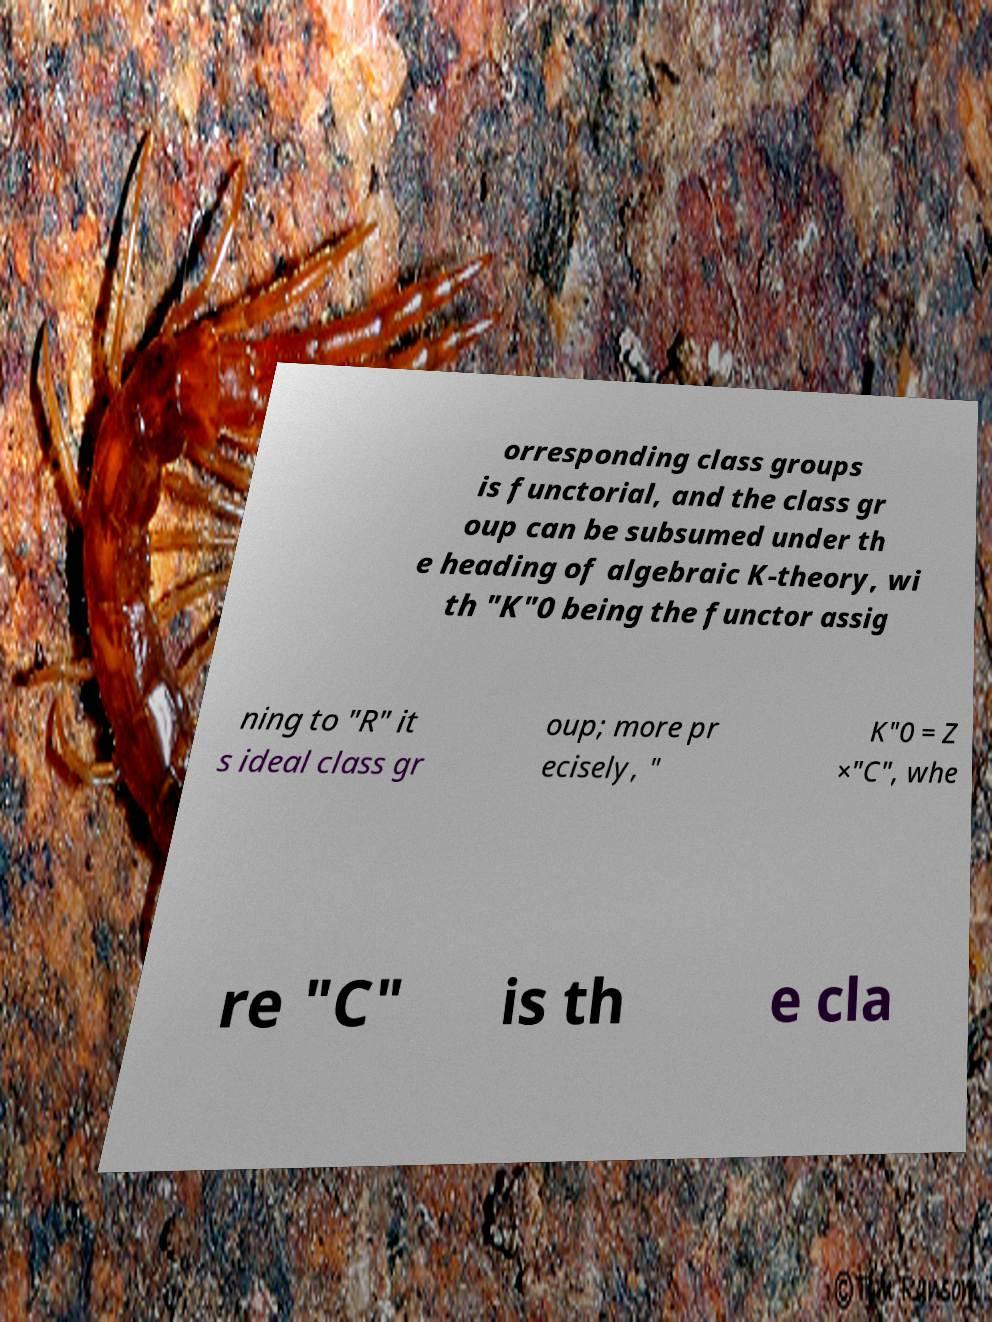For documentation purposes, I need the text within this image transcribed. Could you provide that? orresponding class groups is functorial, and the class gr oup can be subsumed under th e heading of algebraic K-theory, wi th "K"0 being the functor assig ning to "R" it s ideal class gr oup; more pr ecisely, " K"0 = Z ×"C", whe re "C" is th e cla 